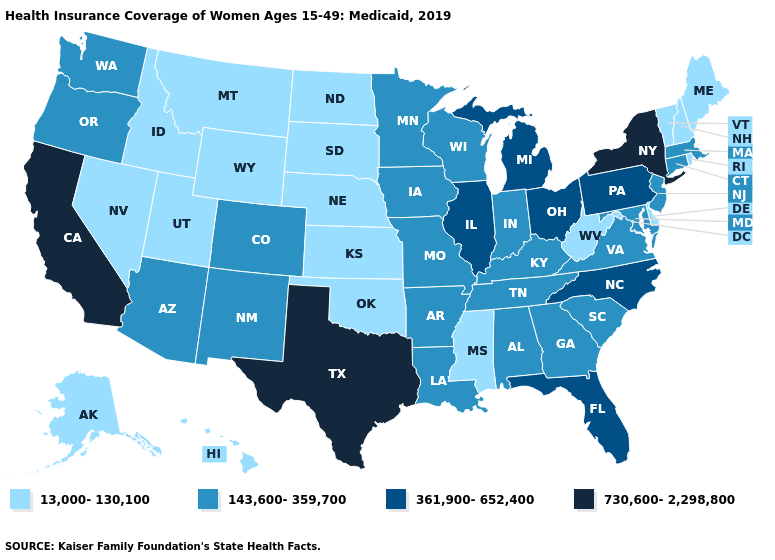How many symbols are there in the legend?
Short answer required. 4. What is the value of Kentucky?
Write a very short answer. 143,600-359,700. Name the states that have a value in the range 730,600-2,298,800?
Short answer required. California, New York, Texas. Which states have the highest value in the USA?
Short answer required. California, New York, Texas. Name the states that have a value in the range 143,600-359,700?
Concise answer only. Alabama, Arizona, Arkansas, Colorado, Connecticut, Georgia, Indiana, Iowa, Kentucky, Louisiana, Maryland, Massachusetts, Minnesota, Missouri, New Jersey, New Mexico, Oregon, South Carolina, Tennessee, Virginia, Washington, Wisconsin. What is the lowest value in the South?
Keep it brief. 13,000-130,100. What is the lowest value in states that border Colorado?
Write a very short answer. 13,000-130,100. What is the value of Wisconsin?
Give a very brief answer. 143,600-359,700. Name the states that have a value in the range 13,000-130,100?
Be succinct. Alaska, Delaware, Hawaii, Idaho, Kansas, Maine, Mississippi, Montana, Nebraska, Nevada, New Hampshire, North Dakota, Oklahoma, Rhode Island, South Dakota, Utah, Vermont, West Virginia, Wyoming. Among the states that border North Carolina , which have the lowest value?
Be succinct. Georgia, South Carolina, Tennessee, Virginia. Is the legend a continuous bar?
Quick response, please. No. Name the states that have a value in the range 143,600-359,700?
Write a very short answer. Alabama, Arizona, Arkansas, Colorado, Connecticut, Georgia, Indiana, Iowa, Kentucky, Louisiana, Maryland, Massachusetts, Minnesota, Missouri, New Jersey, New Mexico, Oregon, South Carolina, Tennessee, Virginia, Washington, Wisconsin. Name the states that have a value in the range 143,600-359,700?
Be succinct. Alabama, Arizona, Arkansas, Colorado, Connecticut, Georgia, Indiana, Iowa, Kentucky, Louisiana, Maryland, Massachusetts, Minnesota, Missouri, New Jersey, New Mexico, Oregon, South Carolina, Tennessee, Virginia, Washington, Wisconsin. Does New York have the highest value in the Northeast?
Keep it brief. Yes. 